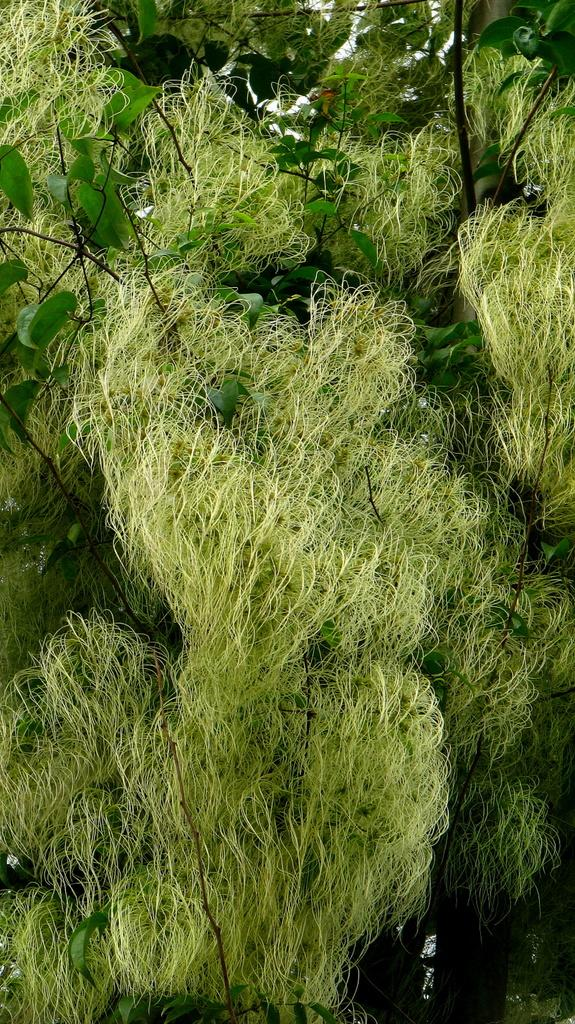What type of vegetation is present in the image? The image contains trees. What is a characteristic feature of the trees in the image? The trees have leaves. What color are the trees and leaves in the image? The trees and leaves are in green color. Can you see any stars in the image? There are no stars visible in the image; it features trees with leaves in green color. 